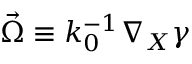<formula> <loc_0><loc_0><loc_500><loc_500>\vec { \Omega } \equiv k _ { 0 } ^ { - 1 } \nabla _ { X } \gamma</formula> 